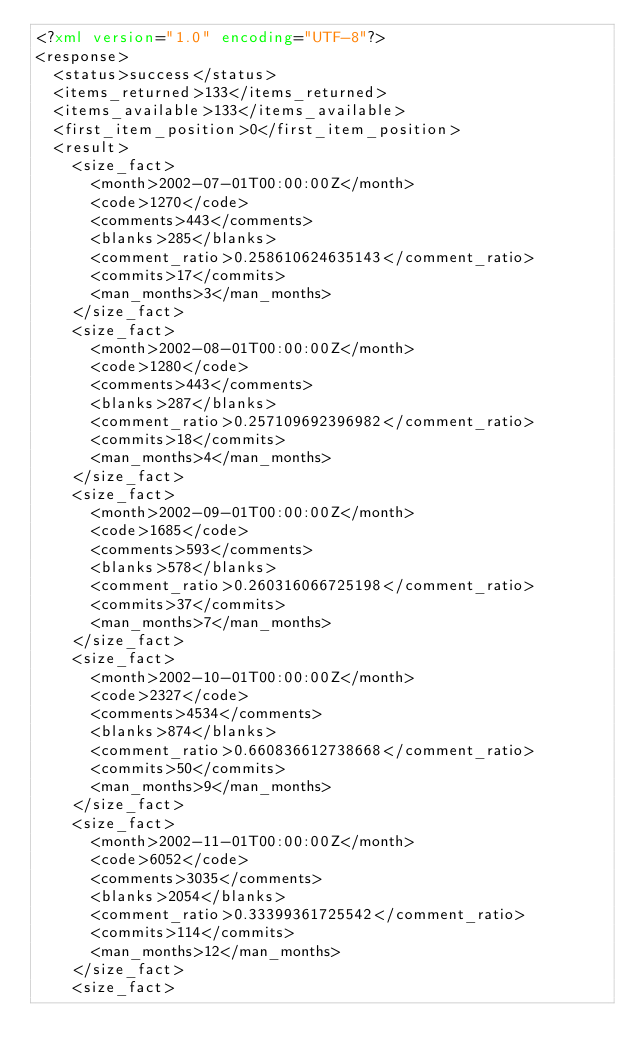Convert code to text. <code><loc_0><loc_0><loc_500><loc_500><_XML_><?xml version="1.0" encoding="UTF-8"?>
<response>
  <status>success</status>
  <items_returned>133</items_returned>
  <items_available>133</items_available>
  <first_item_position>0</first_item_position>
  <result>
    <size_fact>
      <month>2002-07-01T00:00:00Z</month>
      <code>1270</code>
      <comments>443</comments>
      <blanks>285</blanks>
      <comment_ratio>0.258610624635143</comment_ratio>
      <commits>17</commits>
      <man_months>3</man_months>
    </size_fact>
    <size_fact>
      <month>2002-08-01T00:00:00Z</month>
      <code>1280</code>
      <comments>443</comments>
      <blanks>287</blanks>
      <comment_ratio>0.257109692396982</comment_ratio>
      <commits>18</commits>
      <man_months>4</man_months>
    </size_fact>
    <size_fact>
      <month>2002-09-01T00:00:00Z</month>
      <code>1685</code>
      <comments>593</comments>
      <blanks>578</blanks>
      <comment_ratio>0.260316066725198</comment_ratio>
      <commits>37</commits>
      <man_months>7</man_months>
    </size_fact>
    <size_fact>
      <month>2002-10-01T00:00:00Z</month>
      <code>2327</code>
      <comments>4534</comments>
      <blanks>874</blanks>
      <comment_ratio>0.660836612738668</comment_ratio>
      <commits>50</commits>
      <man_months>9</man_months>
    </size_fact>
    <size_fact>
      <month>2002-11-01T00:00:00Z</month>
      <code>6052</code>
      <comments>3035</comments>
      <blanks>2054</blanks>
      <comment_ratio>0.33399361725542</comment_ratio>
      <commits>114</commits>
      <man_months>12</man_months>
    </size_fact>
    <size_fact></code> 